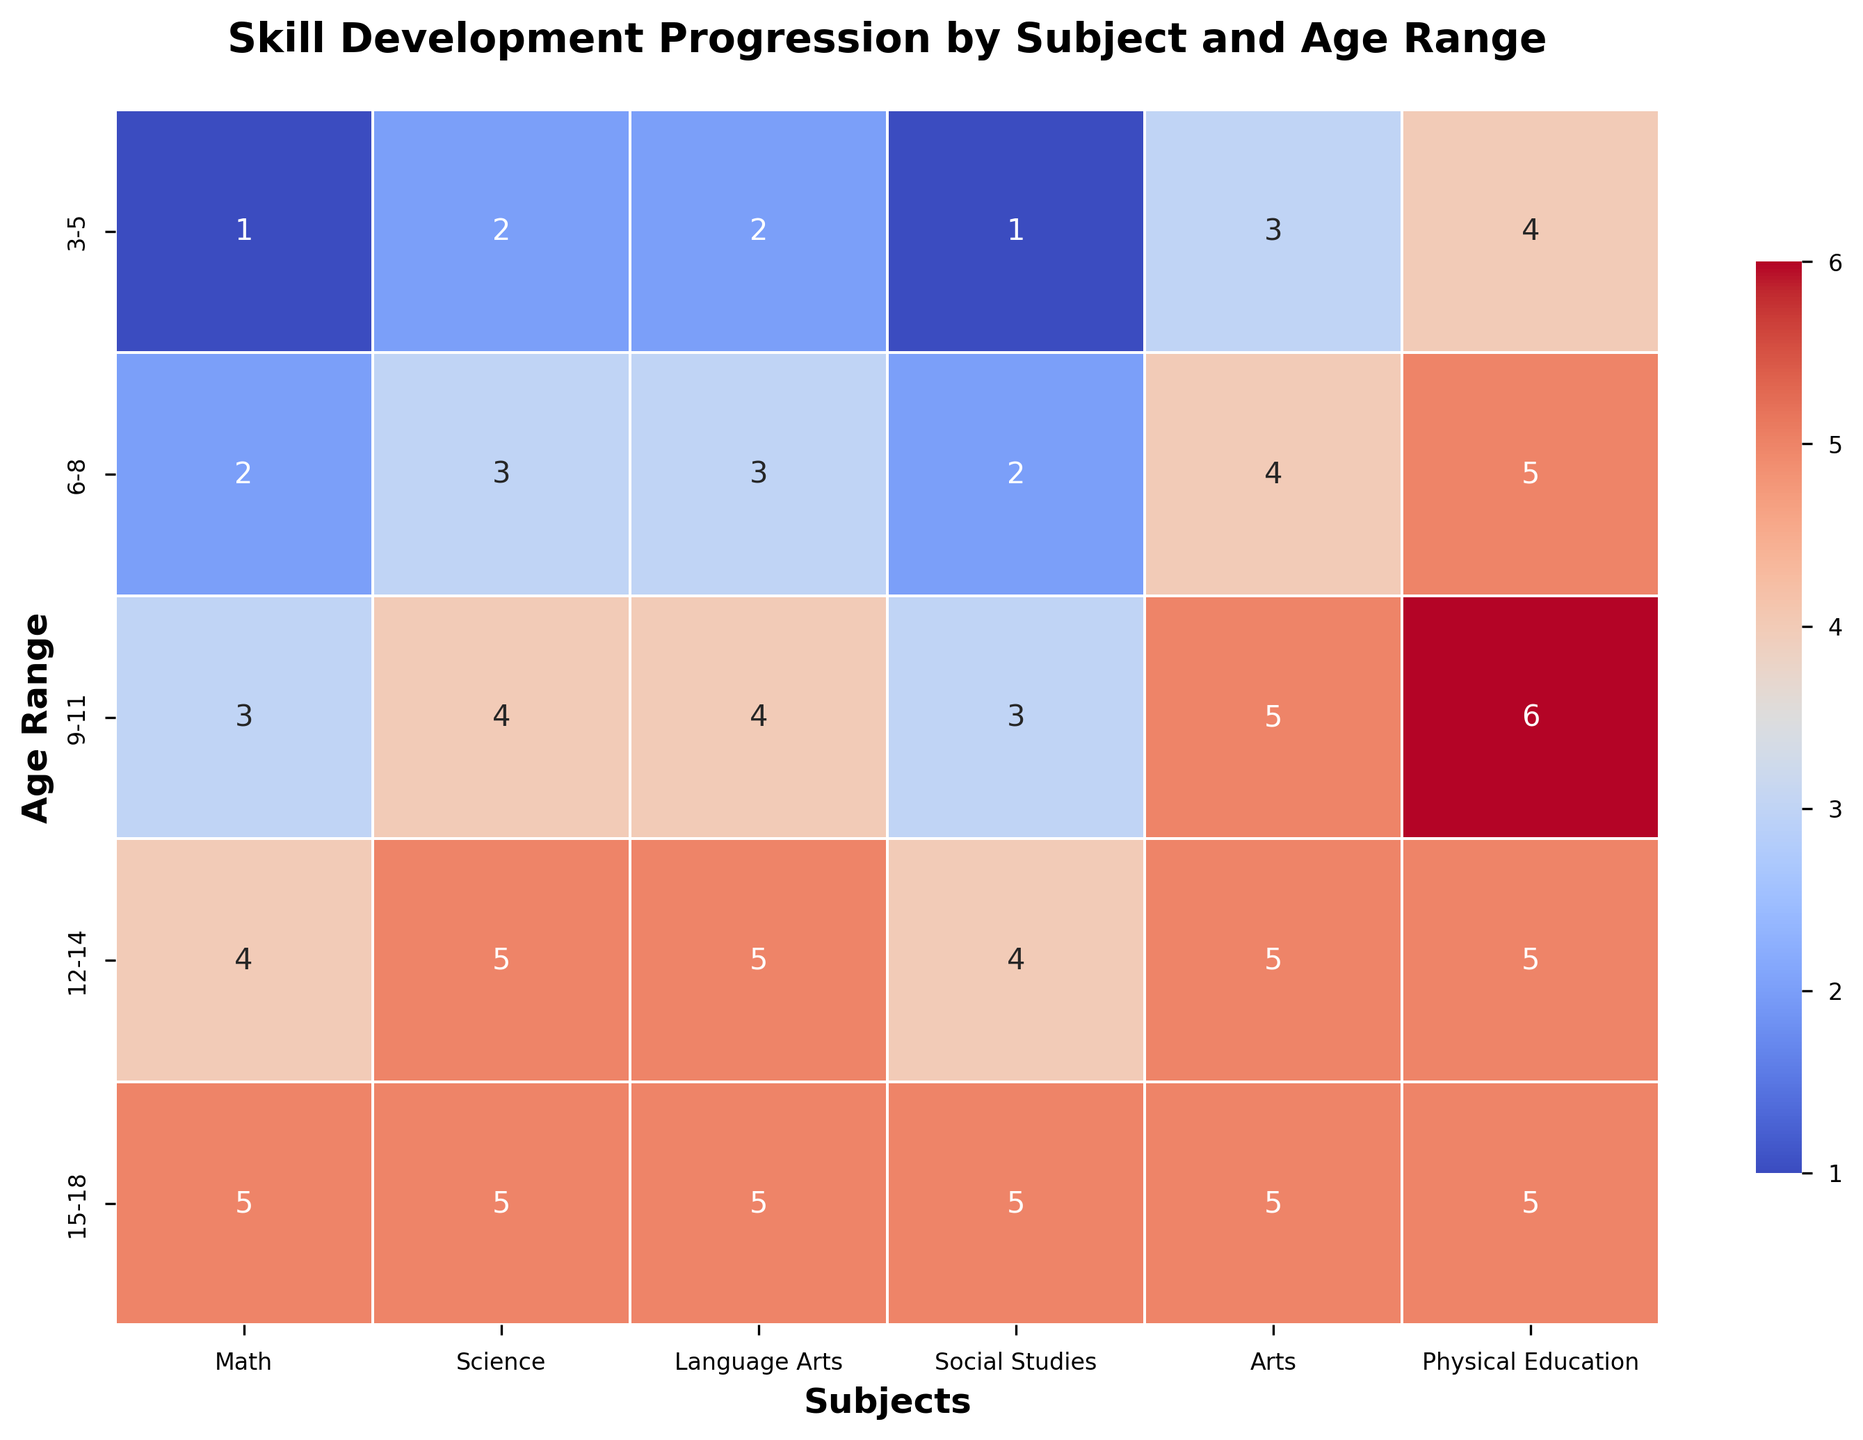What is the skill progression in Physical Education from age range 3-5 to 15-18? The figure shows the skill values for Physical Education along the age range y-axis. We start at 4 for ages 3-5, progress to 5 for ages 6-8, then to 6 for ages 9-11, stay at 5 for ages 12-14, and remain at 5 for ages 15-18. So, the progression is 4 to 5 to 6 to 5 to 5.
Answer: 4, 5, 6, 5, 5 Which subject has a skill value of 3 for the 3-5 age range? Looking at the row corresponding to the 3-5 age range, we examine which subjects have a value of 3. According to the heatmap, the subject with a 3 is Arts.
Answer: Arts Does Science or Social Studies have a higher skill value for the 9-11 age range? In the heatmap, locate the row for age range 9-11. Compare the values for Science (4) and Social Studies (3). Since 4 is greater than 3, Science has a higher value.
Answer: Science What is the difference in skill values for Math between ages 6-8 and 12-14? Find the Math values for age ranges 6-8 (value 2) and 12-14 (value 4). The difference is calculated as 4 - 2 = 2.
Answer: 2 Which age range has the most uniform skill values across all subjects? We examine each age range's row to see if all subjects have roughly the same values. The 15-18 age range has uniform skill values of 5 across all subjects, more uniform compared to other age ranges.
Answer: 15-18 What is the average skill value for Social Studies across all age ranges? We add up the Social Studies values for all age ranges: 1 (3-5) + 2 (6-8) + 3 (9-11) + 4 (12-14) + 5 (15-18). The sum is 15, and there are 5 age ranges, so we divide 15 by 5.
Answer: 3 Which subject's skill value shows the least change across age ranges? Visual inspection of each column (subject) shows that Arts and Physical Education remain more constant, but Physical Education changes less: from 4 to 5, 6, then back to 5. Thus, the smallest change is in Physical Education.
Answer: Physical Education How many skill values are 5 across all subjects and age ranges in the heatmap? Count all the occurrences of the number 5. Math = 2 (12-14, 15-18); Science = 2 (12-14, 15-18); Language Arts = 2 (12-14, 15-18); Social Studies = 2 (12-14, 15-18); Arts = 1 (15-18); P.E. = 2 (12-14, 15-18). The total is 11.
Answer: 11 Which age range exhibits the most significant increase in Math skill values compared to the previous age range? Compare each age jump: from 1 (3-5) to 2 (6-8), an increase of 1; from 2 (6-8) to 3 (9-11), an increase of 1; from 3 (9-11) to 4 (12-14), an increase of 1; from 4 (12-14) to 5 (15-18), an increase of 1. All increases are the same.
Answer: All increases are the same 